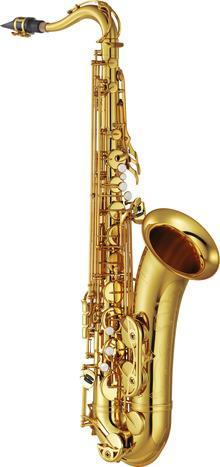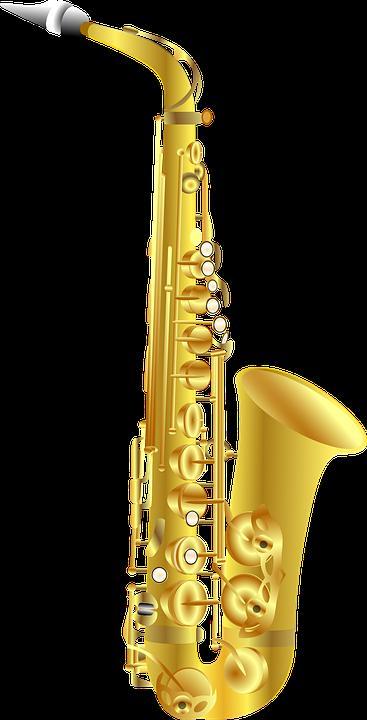The first image is the image on the left, the second image is the image on the right. For the images displayed, is the sentence "The full length of two saxophones are shown, each of them a different color, but both with a mouthpiece of the same shape." factually correct? Answer yes or no. No. The first image is the image on the left, the second image is the image on the right. Evaluate the accuracy of this statement regarding the images: "A gold-colored right-facing saxophone is displayed fully upright on a black background.". Is it true? Answer yes or no. Yes. 